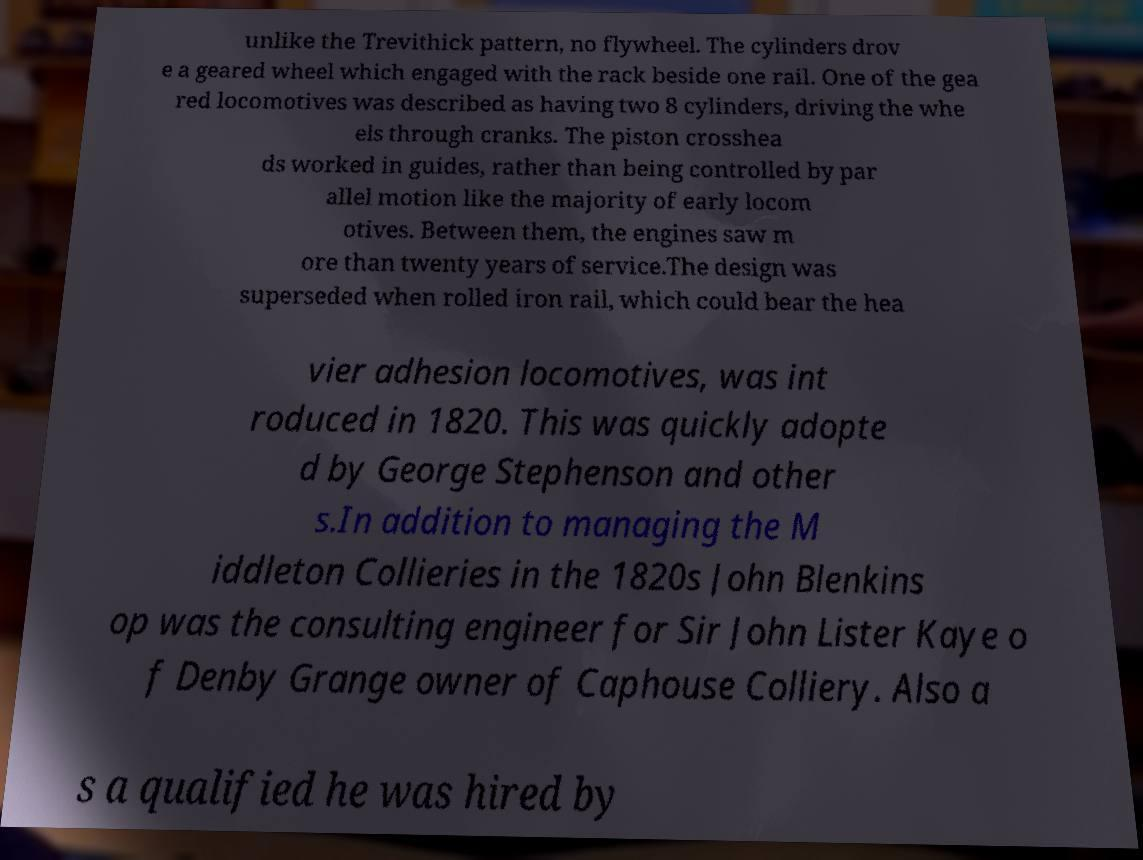Can you accurately transcribe the text from the provided image for me? unlike the Trevithick pattern, no flywheel. The cylinders drov e a geared wheel which engaged with the rack beside one rail. One of the gea red locomotives was described as having two 8 cylinders, driving the whe els through cranks. The piston crosshea ds worked in guides, rather than being controlled by par allel motion like the majority of early locom otives. Between them, the engines saw m ore than twenty years of service.The design was superseded when rolled iron rail, which could bear the hea vier adhesion locomotives, was int roduced in 1820. This was quickly adopte d by George Stephenson and other s.In addition to managing the M iddleton Collieries in the 1820s John Blenkins op was the consulting engineer for Sir John Lister Kaye o f Denby Grange owner of Caphouse Colliery. Also a s a qualified he was hired by 